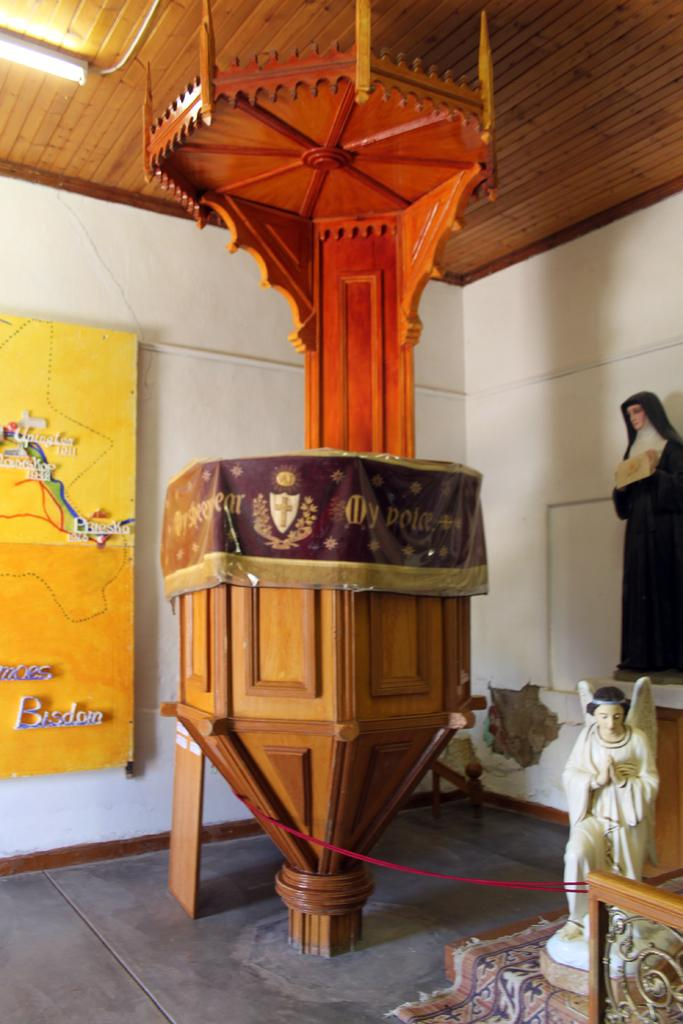What type of object is made of wood in the image? There is a wooden object in the image. What other items can be seen in the image besides the wooden object? There are statues in the image. What is the background of the image made of? There is a wall in the image. What is on the wall in the image? There is a yellow color board on the wall. Can you see a person holding a clover in the image? There is no person or clover present in the image. What type of connection is depicted between the wooden object and the statues in the image? There is no connection between the wooden object and the statues mentioned in the image. 